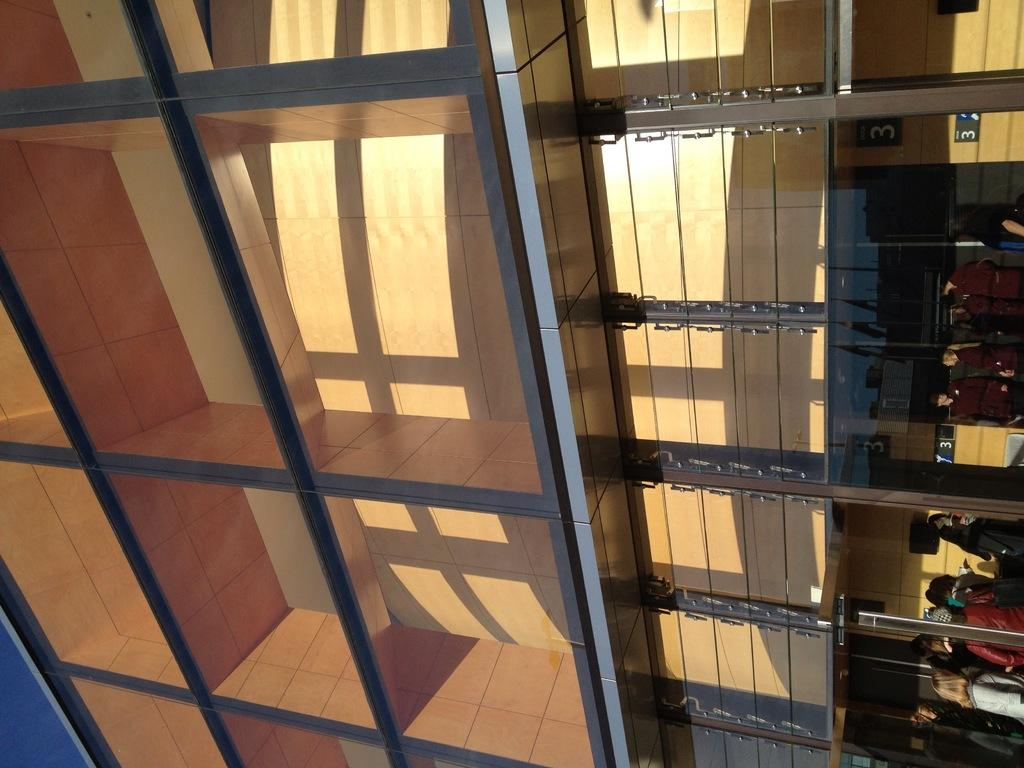What type of building is shown in the image? The building in the image has pillars and glass. Where are the people located in the image? There is a group of people standing on the right side of the image. What else can be seen in the image besides the building and people? Boards are visible in the image. What is the texture of the rail in the image? There is no rail present in the image. 